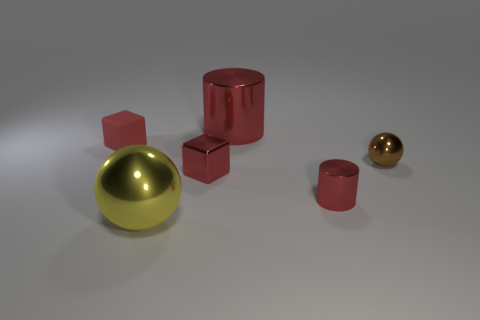Add 1 blue cylinders. How many objects exist? 7 Subtract all spheres. How many objects are left? 4 Add 5 large metal spheres. How many large metal spheres exist? 6 Subtract 0 gray blocks. How many objects are left? 6 Subtract all big spheres. Subtract all metallic things. How many objects are left? 0 Add 1 small brown objects. How many small brown objects are left? 2 